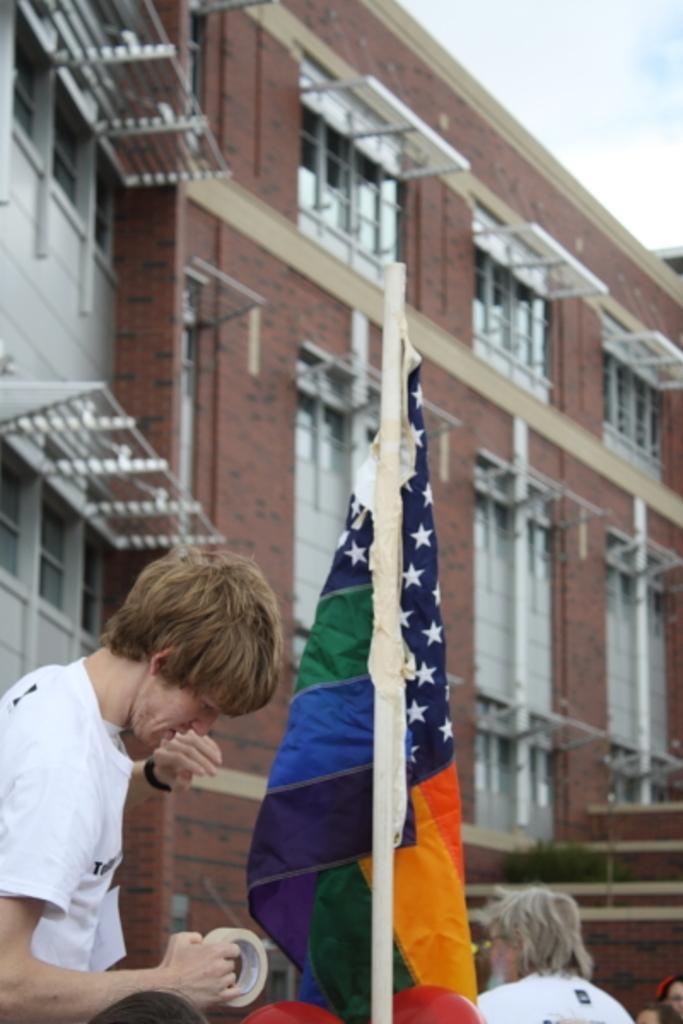In one or two sentences, can you explain what this image depicts? In this image I can see some people. I can see the flag. In the background, I can see a building with the windows. At the top I can see clouds in the sky. 